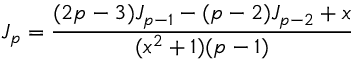Convert formula to latex. <formula><loc_0><loc_0><loc_500><loc_500>J _ { p } = \frac { ( 2 p - 3 ) J _ { p - 1 } - ( p - 2 ) J _ { p - 2 } + x } { ( x ^ { 2 } + 1 ) ( p - 1 ) }</formula> 